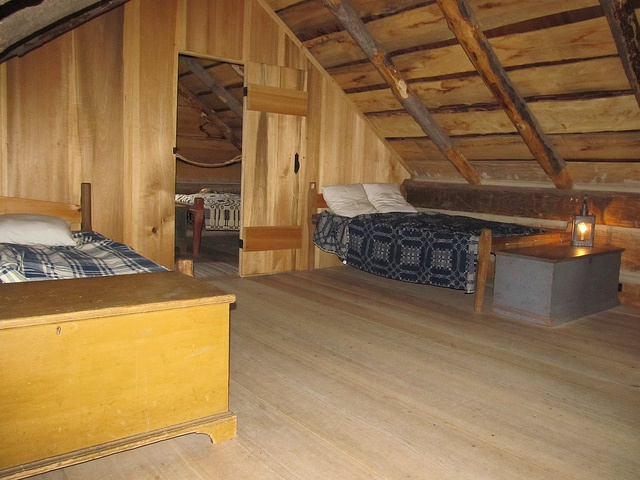Describe the objects in this image and their specific colors. I can see bed in gray, black, maroon, and darkgray tones, bed in gray, maroon, darkgray, and olive tones, and bed in gray, maroon, and black tones in this image. 